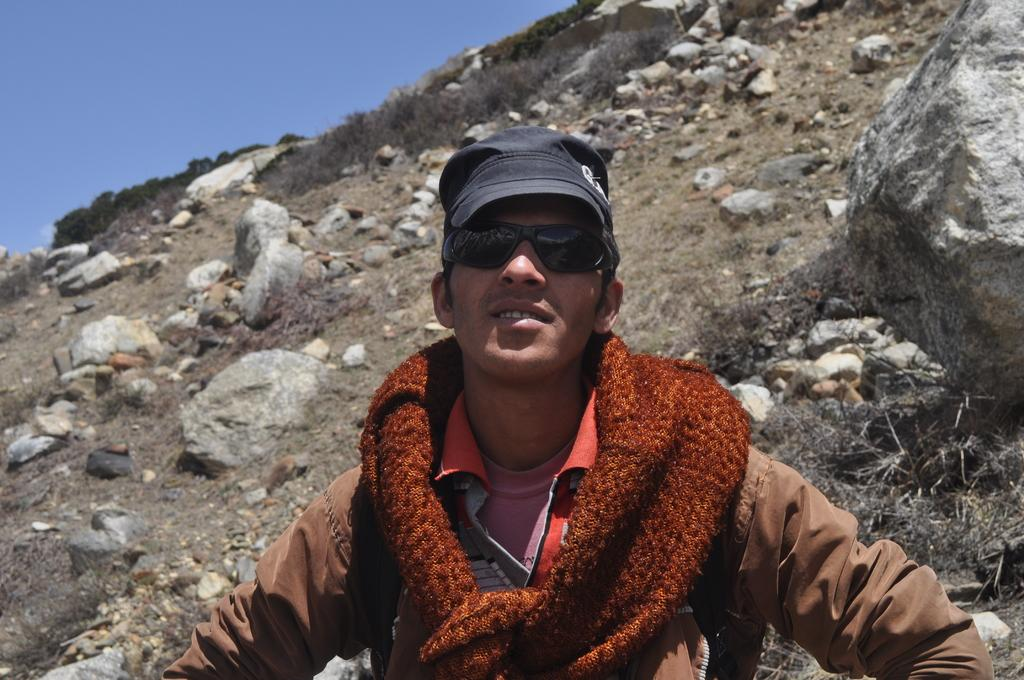What is the main subject of the image? There is a man standing in the image. What is the man wearing on his face? The man is wearing black color shades. What color are the clothes the man is wearing? The man is wearing black color clothes. What can be seen in the background of the image? There are rocks, grass, and the sky visible in the background of the image. What type of ornament is hanging from the man's neck in the image? There is no ornament visible around the man's neck in the image. How does the man measure the distance between the rocks in the image? The image does not show the man measuring anything, nor is there any indication of him doing so. 